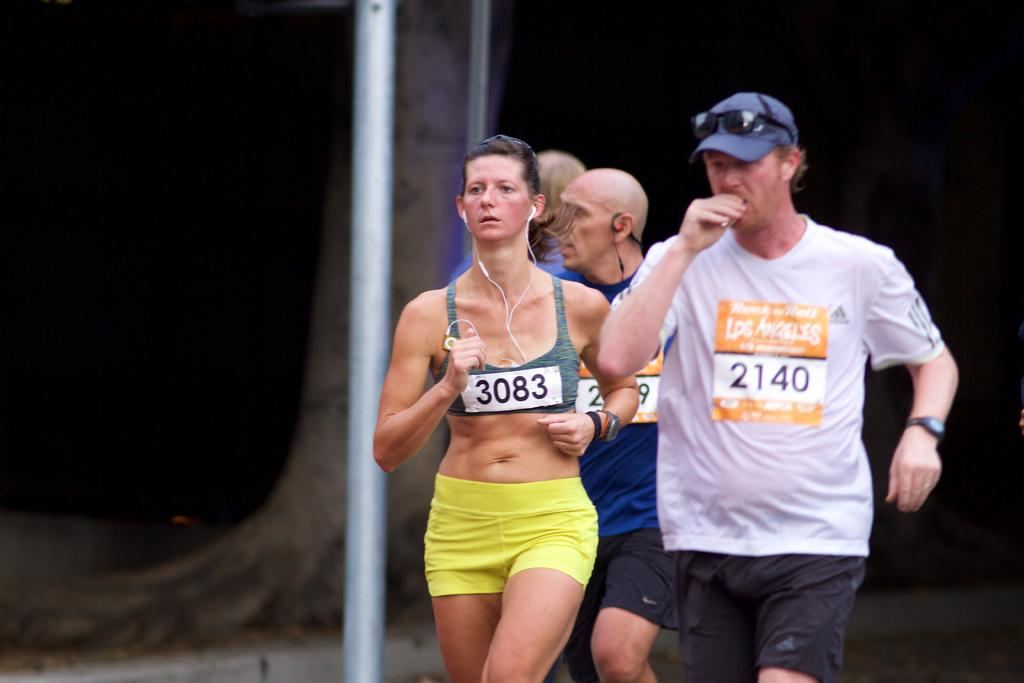How many people are in the image? There are four persons in the image. What can be seen besides the people in the image? There is a white pole in the image. What is visible in the background of the image? There is a tree visible in the background of the image. How would you describe the lighting in the image? The image appears to be dark. What type of rhythm can be heard from the railway in the image? There is no railway present in the image, so it is not possible to determine the rhythm of any trains. 